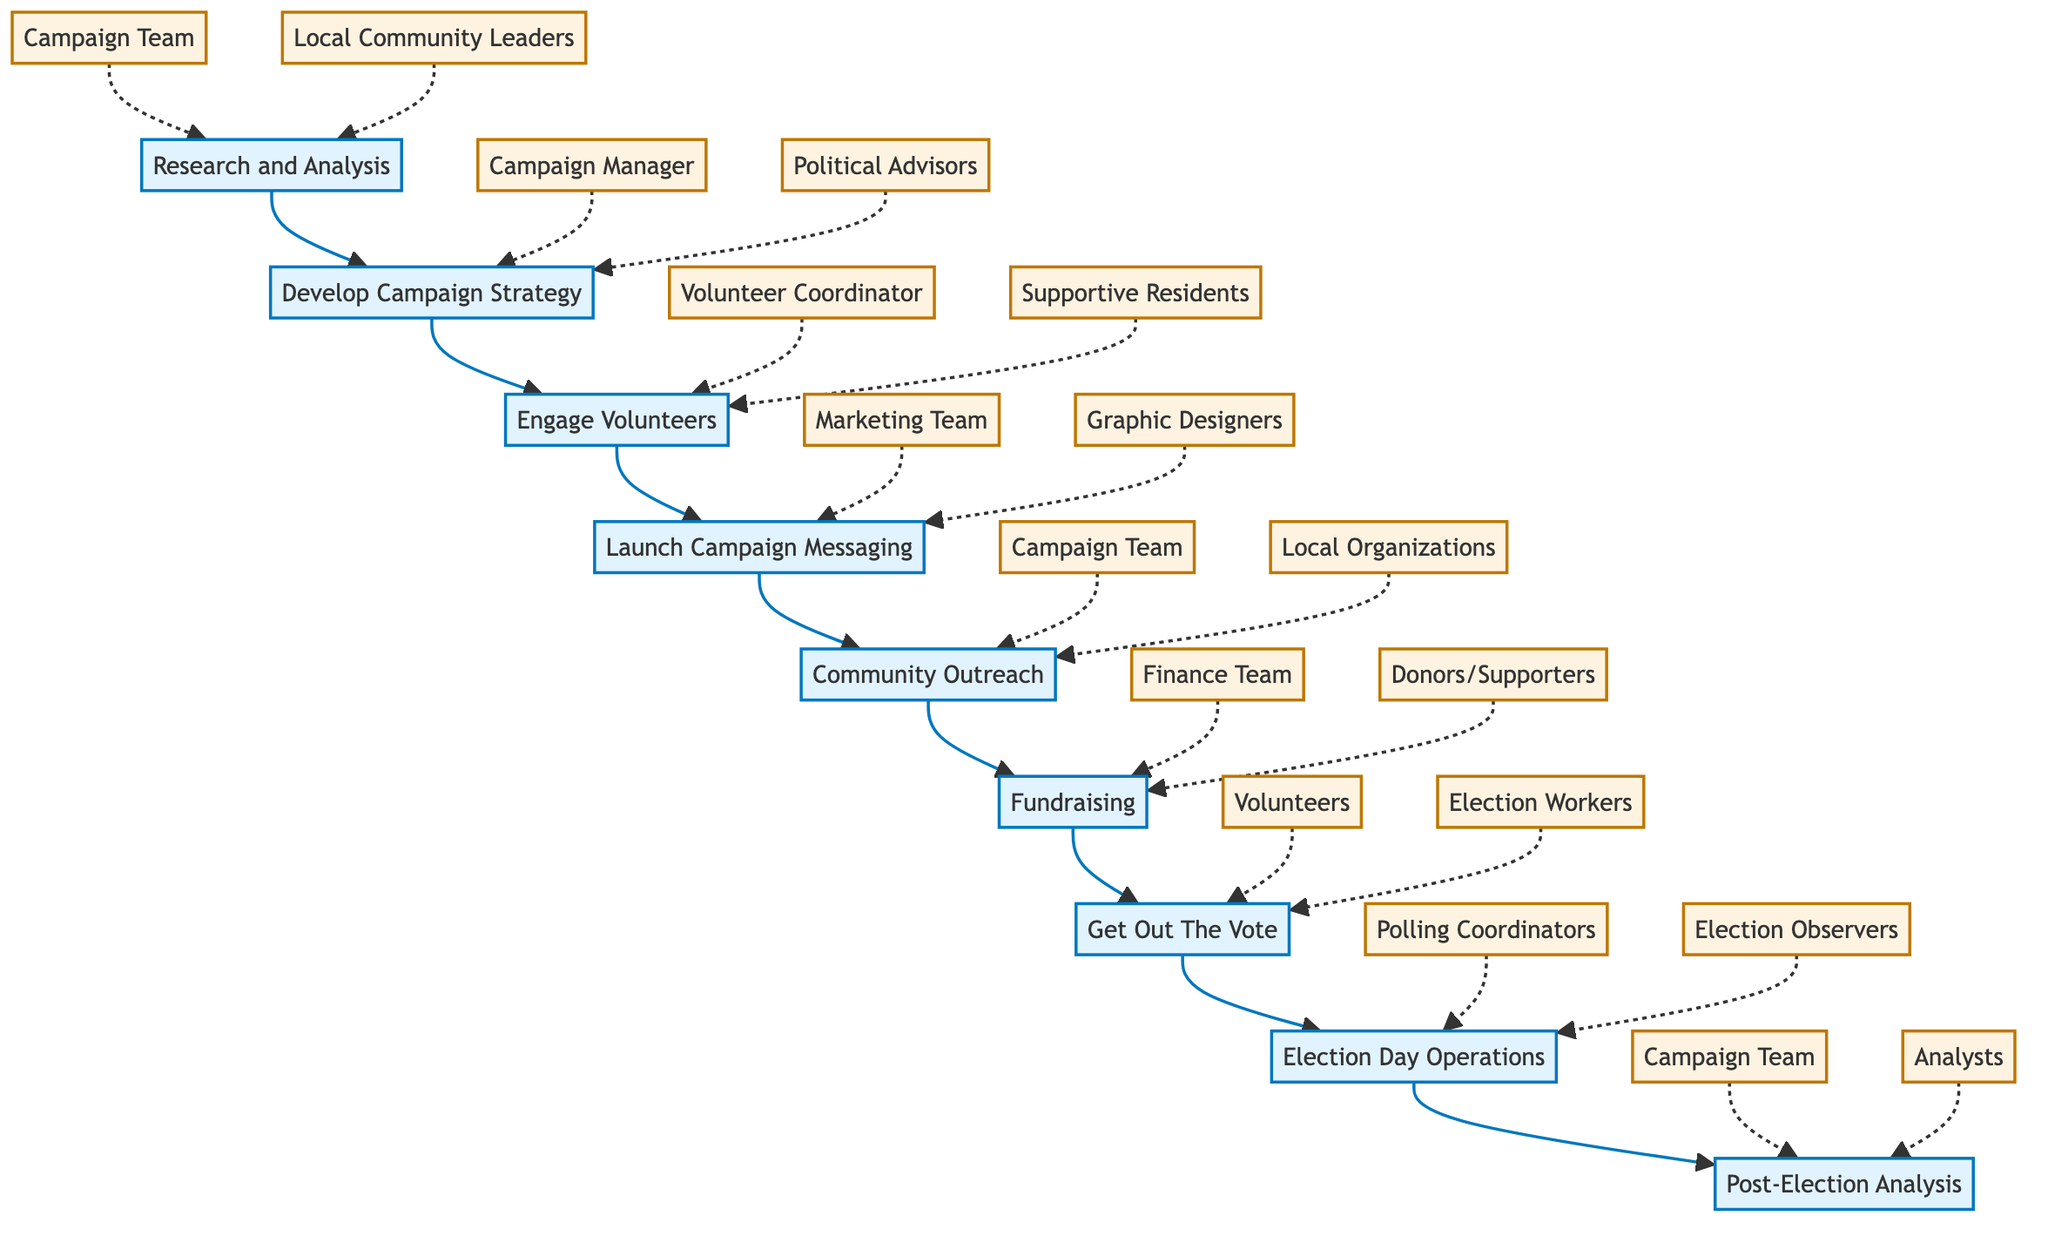What is the first step in the campaign process? The diagram shows that the first step in the campaign process is "Research and Analysis," as it is positioned at the beginning of the flow chart.
Answer: Research and Analysis How many stakeholders are involved in the "Engage Volunteers" step? In the diagram, the "Engage Volunteers" step has two stakeholders associated with it: "Volunteer Coordinator" and "Supportive Residents."
Answer: 2 Which stakeholders are connected to the "Fundraising" step? The diagram specifically indicates that "Finance Team" and "Donors/Supporters" are the stakeholders connected to the "Fundraising" step.
Answer: Finance Team, Donors/Supporters What is the last step in the campaign process? According to the flow chart, the last step in the campaign process is "Post-Election Analysis," as it is the final node in the sequence of steps.
Answer: Post-Election Analysis Which step comes after "Community Outreach"? In the flow chart, "Fundraising" comes immediately after "Community Outreach" in the sequence of the campaign process.
Answer: Fundraising How many steps are there in total in the campaign process? The diagram outlines a total of nine steps in the campaign process, indicating a comprehensive approach to the campaign.
Answer: 9 What describes the purpose of the "Get Out The Vote" step? The flowchart states that the purpose of the "Get Out The Vote" step is to mobilize voters to ensure they participate in the election, which indicates its significant role in the overall campaign.
Answer: Mobilizing voters Which step involves local community leaders? "Research and Analysis" is the step that involves local community leaders as one of its stakeholders, highlighting their importance in understanding residents' needs.
Answer: Research and Analysis What is the relationship between "Launch Campaign Messaging" and "Community Outreach"? The diagram illustrates that "Launch Campaign Messaging" directly precedes "Community Outreach," indicating a sequential relationship where messaging leads into outreach efforts.
Answer: Sequential relationship 